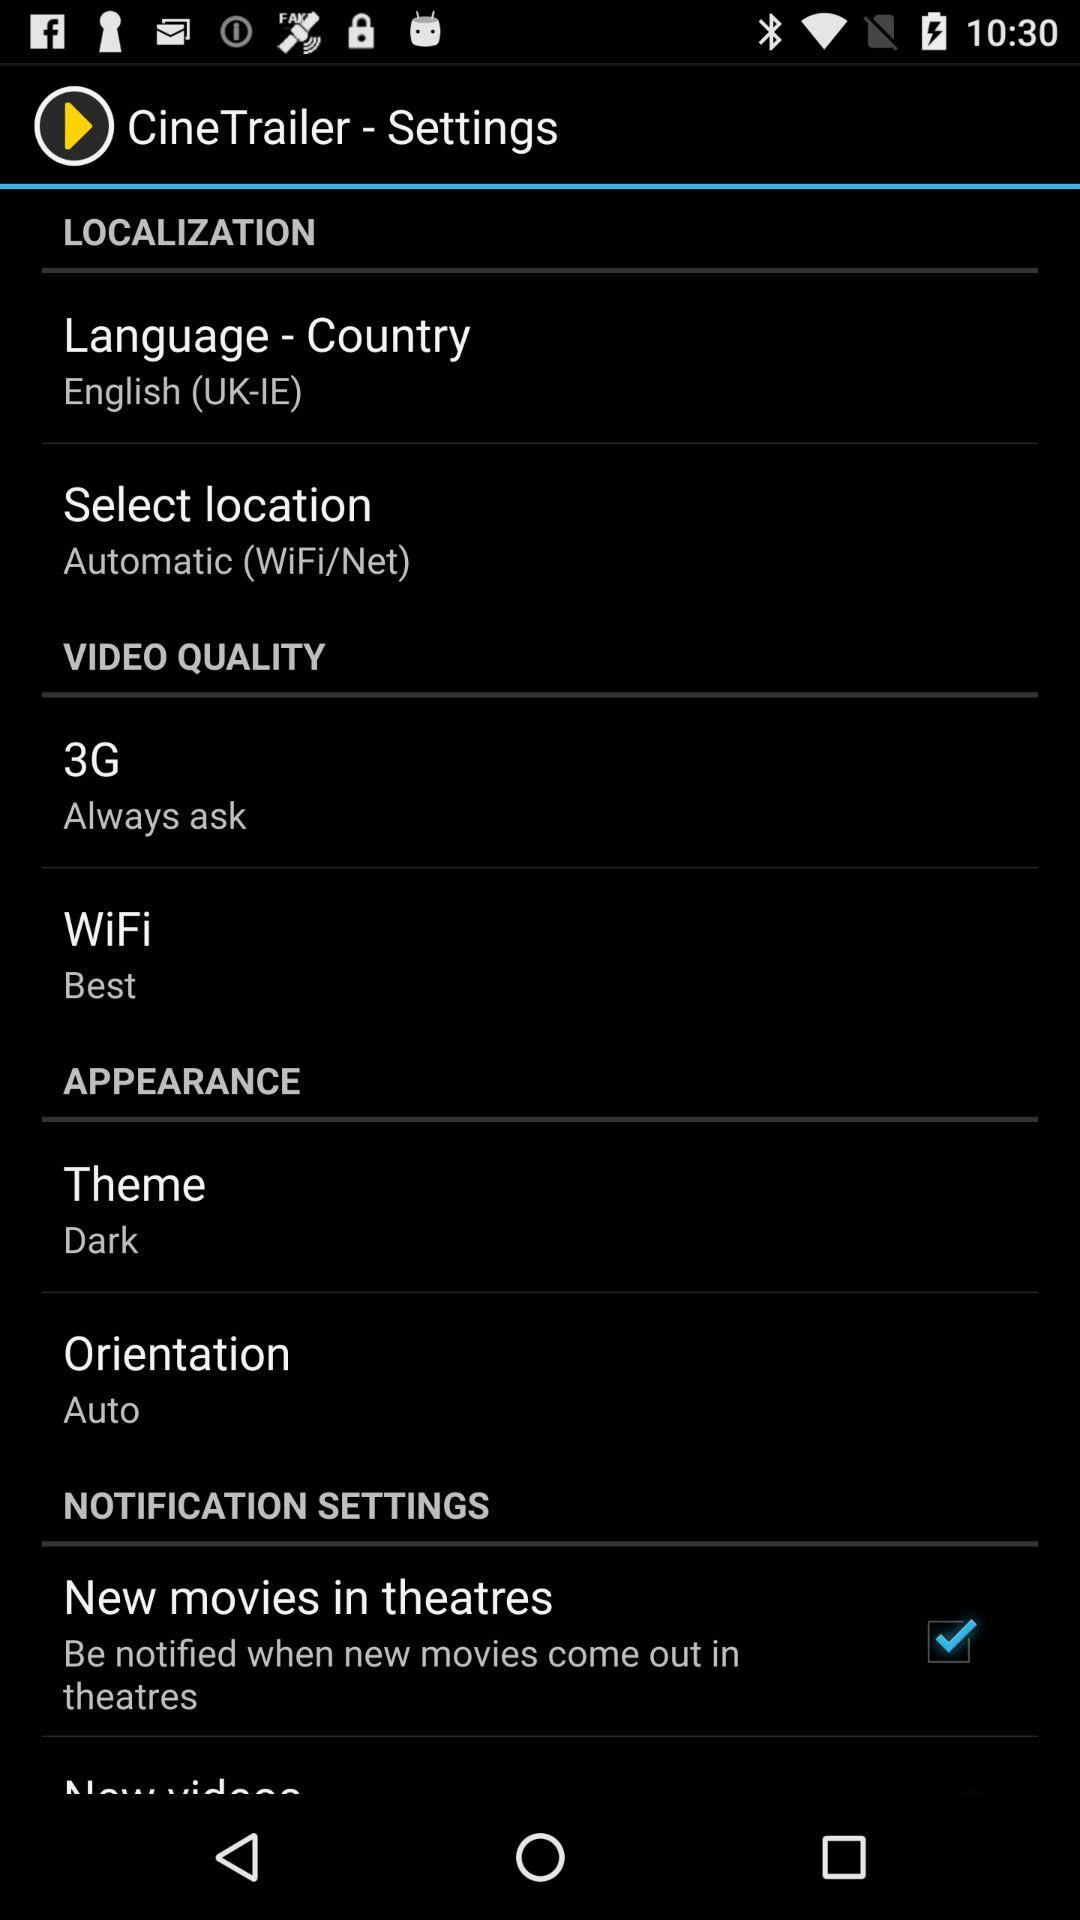What is the selected "Orientation"? The selected "Orientation" is "Auto". 